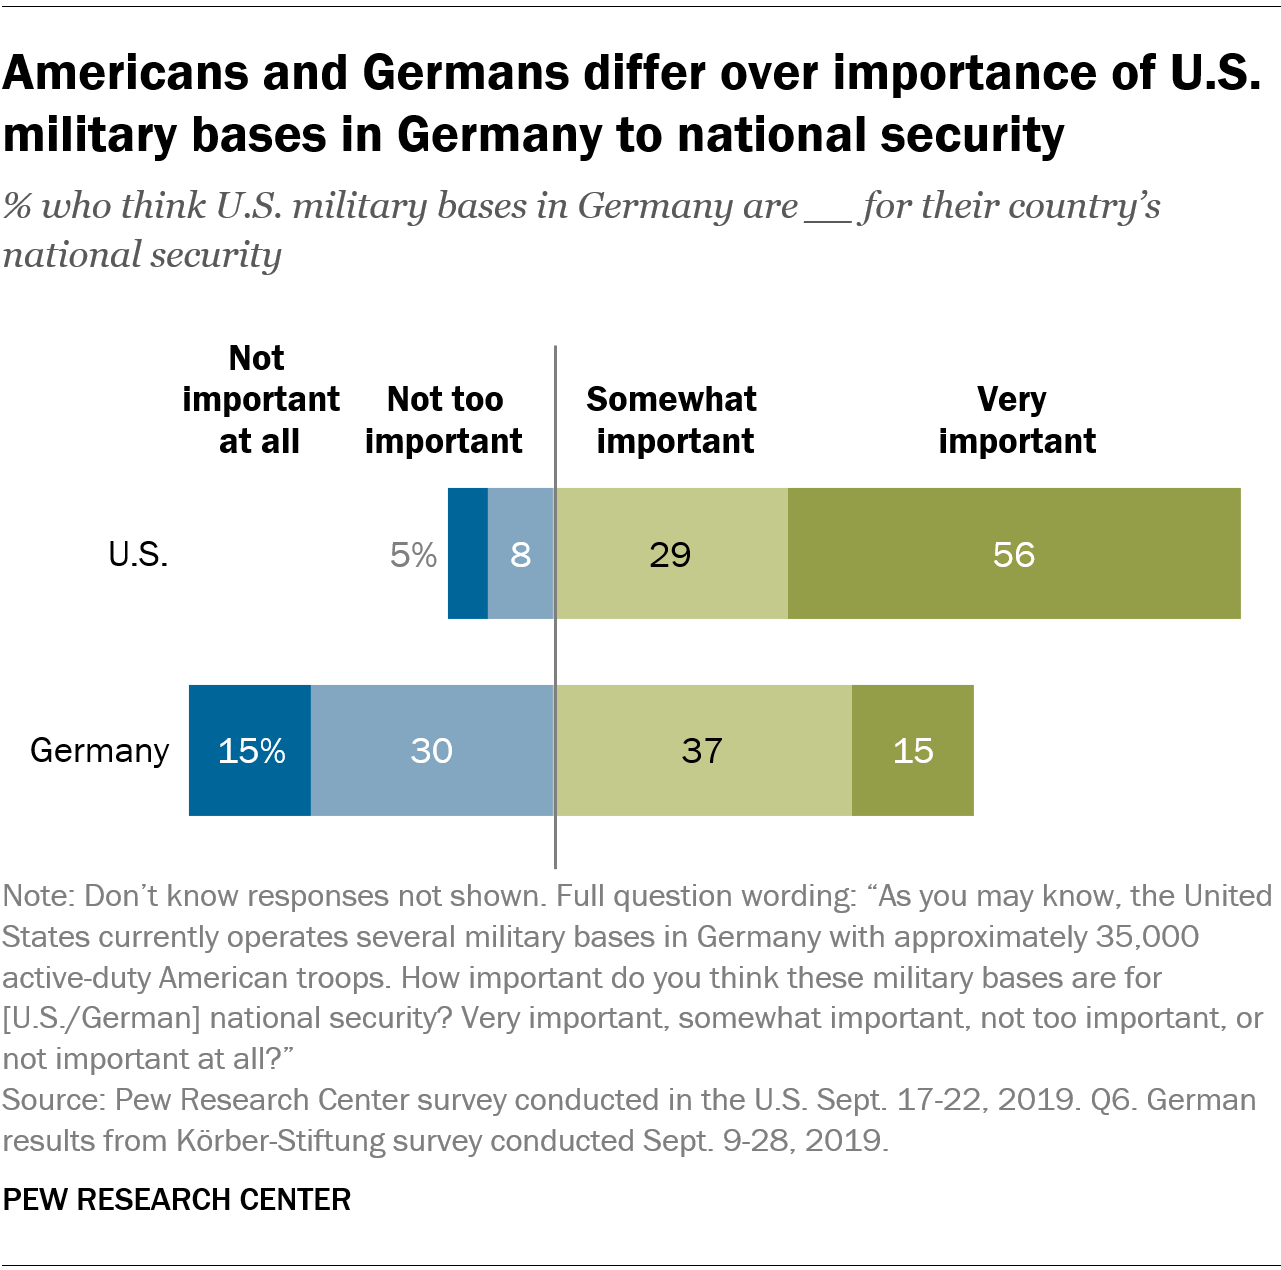Point out several critical features in this image. The ratio of blue bar and green bar in Germany is 0.042361111... The value of the green bars in the U.S. is 56. 